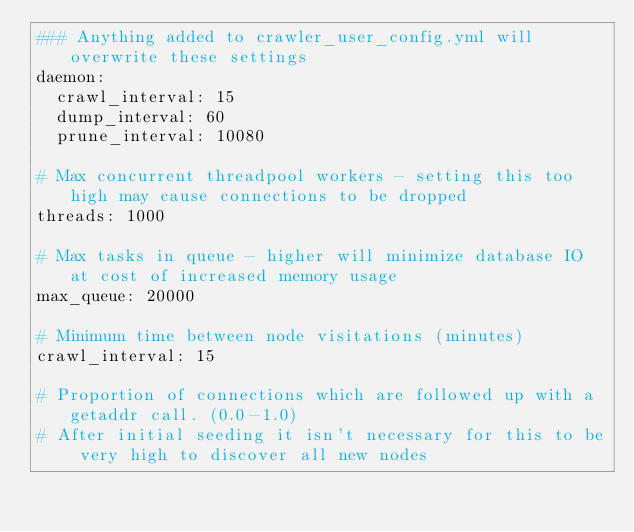<code> <loc_0><loc_0><loc_500><loc_500><_YAML_>### Anything added to crawler_user_config.yml will overwrite these settings
daemon:
  crawl_interval: 15
  dump_interval: 60
  prune_interval: 10080

# Max concurrent threadpool workers - setting this too high may cause connections to be dropped
threads: 1000

# Max tasks in queue - higher will minimize database IO at cost of increased memory usage
max_queue: 20000

# Minimum time between node visitations (minutes)
crawl_interval: 15

# Proportion of connections which are followed up with a getaddr call. (0.0-1.0)
# After initial seeding it isn't necessary for this to be very high to discover all new nodes</code> 